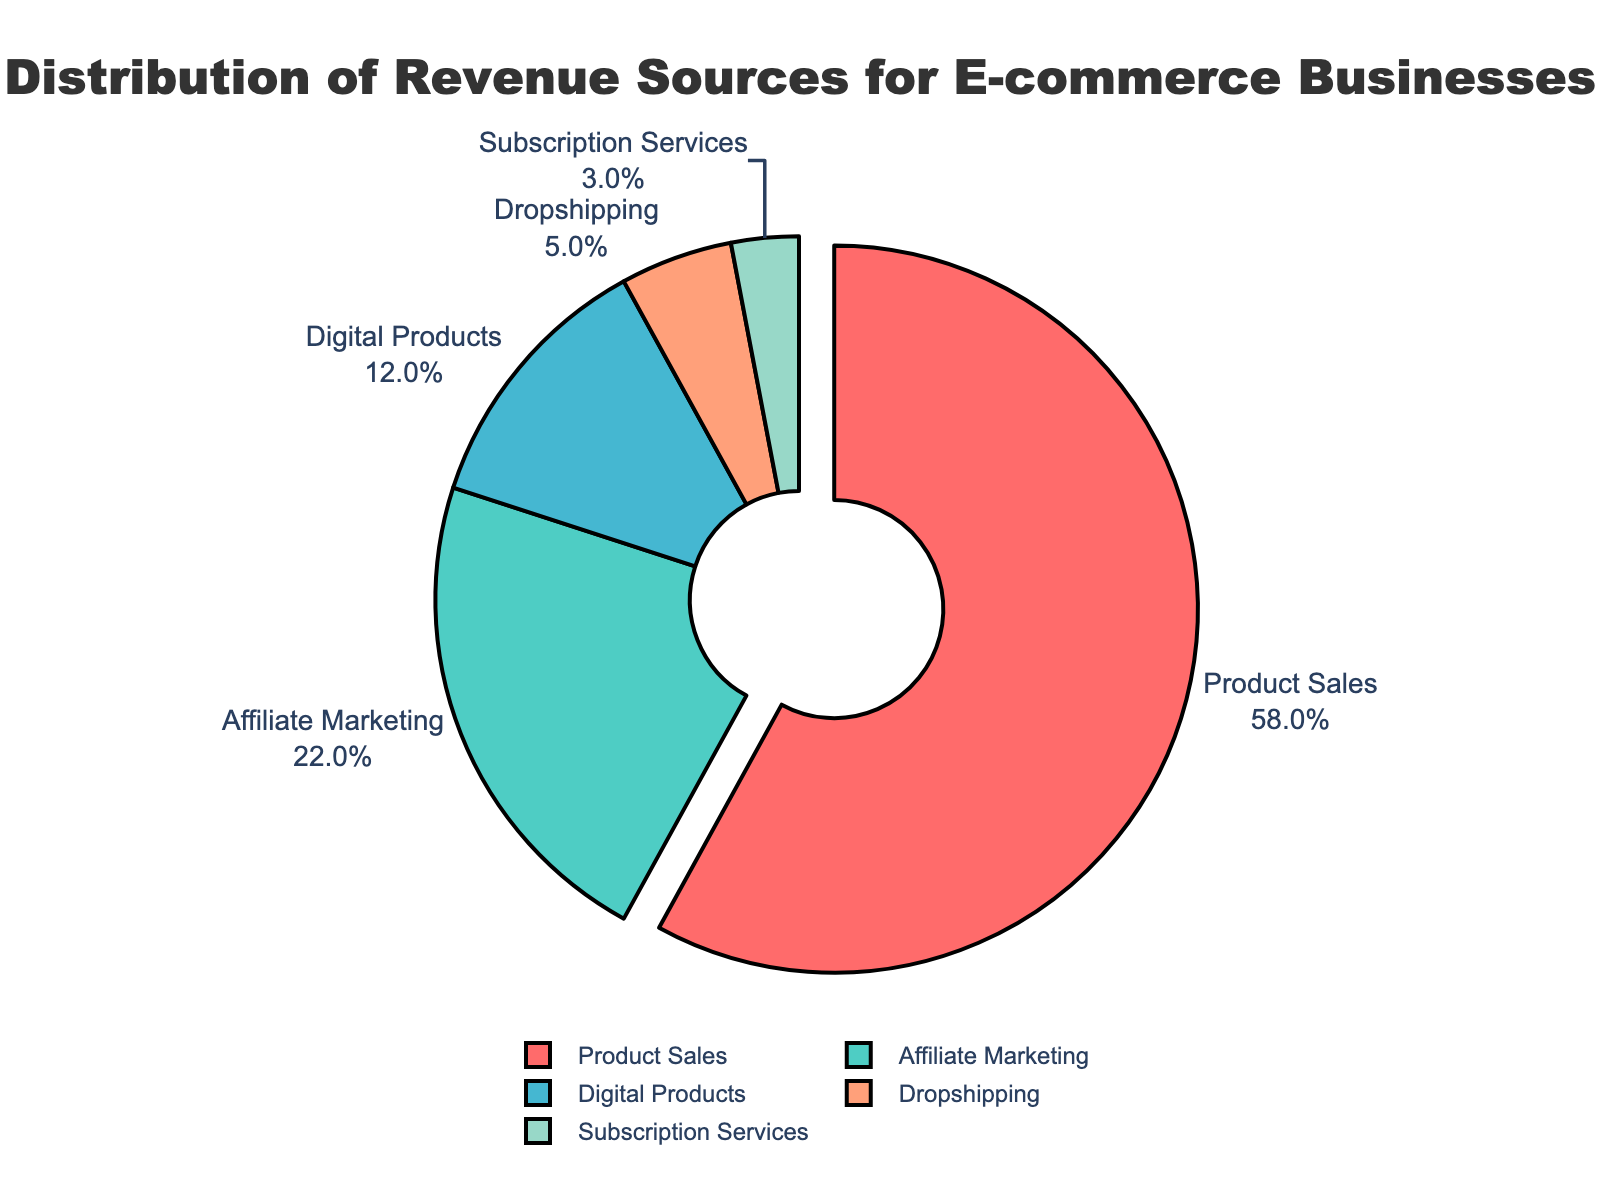Which revenue source has the highest percentage in the pie chart? By looking at the pie chart, it is evident that the largest segment represents product sales. The label and percentage shown outside this segment indicate that product sales have the highest percentage.
Answer: Product Sales Which two revenue sources combined make up more than 50% of the revenue? By adding the percentages of product sales and affiliate marketing (58% + 22%), we get a sum of 80%, which is more than 50%.
Answer: Product Sales and Affiliate Marketing Which is larger: the percentage of revenue from digital products or the combined percentage of dropshipping and subscription services? The percentage for digital products is 12%, while the percentages for dropshipping and subscription services are 5% and 3%, respectively. Adding dropshipping and subscription services gives 5% + 3% = 8%, which is less than 12%.
Answer: Digital Products How much more is the percentage of product sales compared to the sum of dropshipping and subscription services? The percentage for product sales is 58%, and the sum of dropshipping and subscription services is 5% + 3% = 8%. The difference is 58% - 8% = 50%.
Answer: 50% What is the color associated with the affiliate marketing revenue source? From the visual attributes of the pie chart, the segment for affiliate marketing is colored in a slightly greenish shade.
Answer: Green If digital products and dropshipping were combined into a single revenue source, what would their combined percentage be, and how would this new source's position compare with existing revenue sources? The percentages for digital products and dropshipping are 12% and 5%, respectively. Their combined percentage is 12% + 5% = 17%. This new source would occupy the third position, behind product sales (58%) and affiliate marketing (22%).
Answer: 17%, third position What is the approximate visual size (proximity to full circle) of the product sales segment compared to the digital products segment? The product sales segment occupies a significant portion of the pie chart, noting nearly halfway, while the digital products segment is comparatively much smaller, only taking up around one-tenth. The product sales segment is visually much larger.
Answer: Much larger What is the percentage difference between the largest and smallest revenue sources presented? The largest revenue source is product sales at 58%, and the smallest is subscription services at 3%. The percentage difference between them is 58% - 3% = 55%.
Answer: 55% 